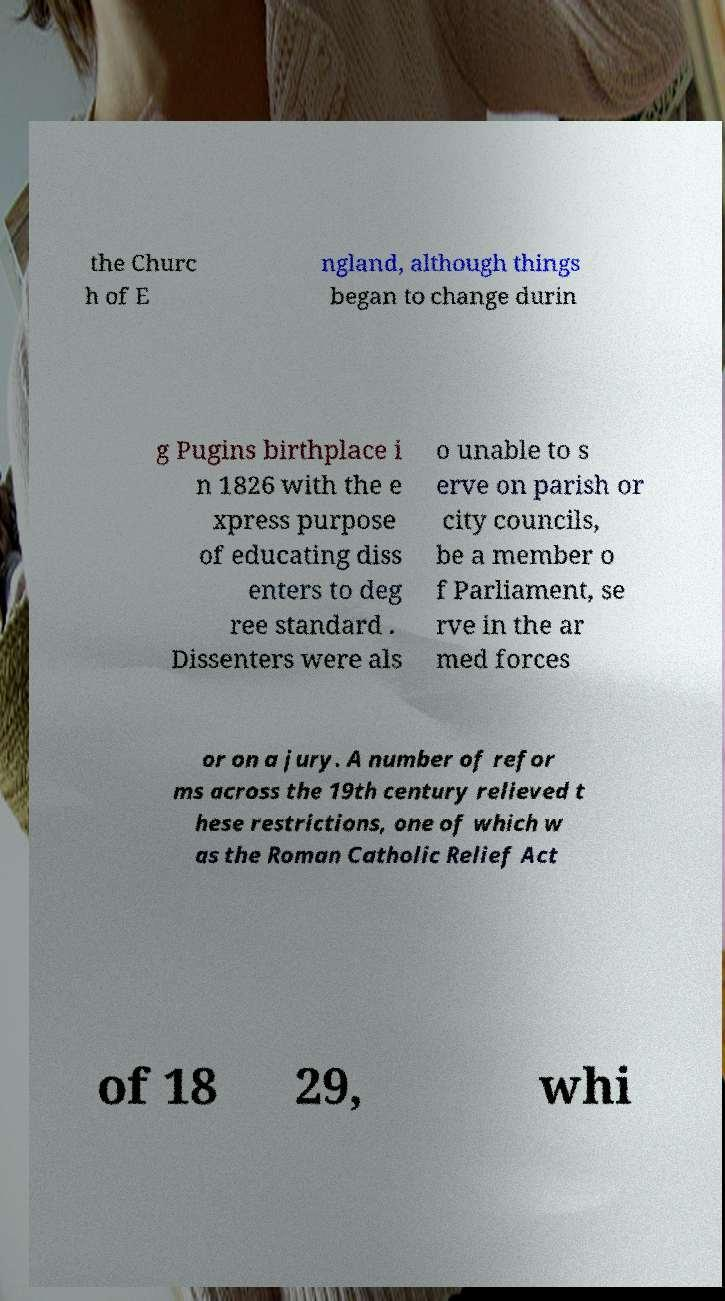Could you assist in decoding the text presented in this image and type it out clearly? the Churc h of E ngland, although things began to change durin g Pugins birthplace i n 1826 with the e xpress purpose of educating diss enters to deg ree standard . Dissenters were als o unable to s erve on parish or city councils, be a member o f Parliament, se rve in the ar med forces or on a jury. A number of refor ms across the 19th century relieved t hese restrictions, one of which w as the Roman Catholic Relief Act of 18 29, whi 